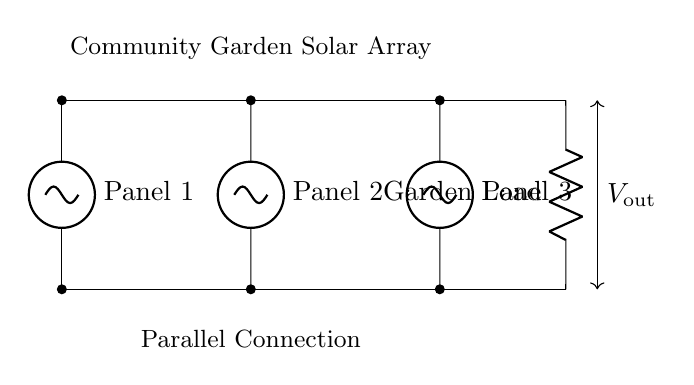What components are in this circuit diagram? The components visible in the diagram are three solar panels and one resistive load. Each solar panel indicates a voltage source, and the load is represented by a resistor.
Answer: Three solar panels and one resistor What type of connection is used for the solar panels? The diagram shows that the solar panels are wired in parallel as indicated by the horizontal wiring layout that connects all positive and negative terminals together.
Answer: Parallel What is the role of the load in the circuit? The load, or the resistor, acts as the device that consumes electrical energy generated by the solar panels, converting it into usable power.
Answer: To consume power What is the voltage output of the solar array? Since the solar panels are connected in parallel, the output voltage will equal the voltage of one solar panel; this is typically represented in the diagram but not specified.
Answer: Equal to one panel voltage How does combining solar panels in parallel affect current? When solar panels are connected in parallel, the total current is the sum of the currents from each panel, leading to higher current output while maintaining the same voltage across the load.
Answer: Increases total current What happens to the output if one solar panel fails? If one of the solar panels fails, the output voltage remains the same, but the total current decreases since only the operational panels contribute to the current.
Answer: Total current decreases What is indicated by the voltage indicator in the diagram? The voltage indicator shows the potential difference across the output terminals of the circuit, which tells us how much voltage is available for the connected load to utilize.
Answer: Voltage across the output terminals 